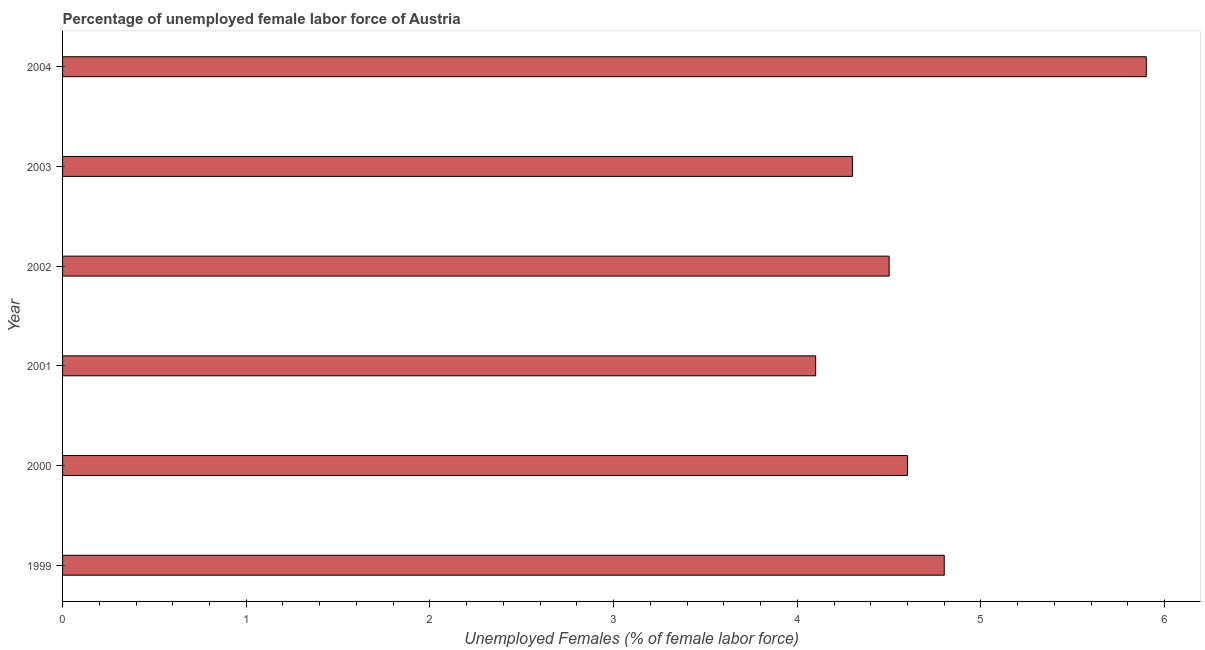Does the graph contain any zero values?
Give a very brief answer. No. What is the title of the graph?
Make the answer very short. Percentage of unemployed female labor force of Austria. What is the label or title of the X-axis?
Give a very brief answer. Unemployed Females (% of female labor force). What is the total unemployed female labour force in 2002?
Ensure brevity in your answer.  4.5. Across all years, what is the maximum total unemployed female labour force?
Make the answer very short. 5.9. Across all years, what is the minimum total unemployed female labour force?
Provide a short and direct response. 4.1. In which year was the total unemployed female labour force minimum?
Provide a succinct answer. 2001. What is the sum of the total unemployed female labour force?
Your answer should be compact. 28.2. What is the difference between the total unemployed female labour force in 2000 and 2003?
Ensure brevity in your answer.  0.3. What is the median total unemployed female labour force?
Your answer should be very brief. 4.55. In how many years, is the total unemployed female labour force greater than 4.8 %?
Provide a succinct answer. 2. What is the ratio of the total unemployed female labour force in 2000 to that in 2003?
Keep it short and to the point. 1.07. Is the difference between the total unemployed female labour force in 1999 and 2003 greater than the difference between any two years?
Offer a very short reply. No. What is the difference between the highest and the second highest total unemployed female labour force?
Your response must be concise. 1.1. Is the sum of the total unemployed female labour force in 2000 and 2003 greater than the maximum total unemployed female labour force across all years?
Your answer should be very brief. Yes. What is the difference between the highest and the lowest total unemployed female labour force?
Keep it short and to the point. 1.8. How many bars are there?
Offer a terse response. 6. What is the difference between two consecutive major ticks on the X-axis?
Make the answer very short. 1. What is the Unemployed Females (% of female labor force) of 1999?
Make the answer very short. 4.8. What is the Unemployed Females (% of female labor force) of 2000?
Your answer should be very brief. 4.6. What is the Unemployed Females (% of female labor force) of 2001?
Provide a succinct answer. 4.1. What is the Unemployed Females (% of female labor force) of 2003?
Make the answer very short. 4.3. What is the Unemployed Females (% of female labor force) in 2004?
Ensure brevity in your answer.  5.9. What is the difference between the Unemployed Females (% of female labor force) in 1999 and 2003?
Offer a terse response. 0.5. What is the difference between the Unemployed Females (% of female labor force) in 2000 and 2002?
Ensure brevity in your answer.  0.1. What is the difference between the Unemployed Females (% of female labor force) in 2000 and 2003?
Your answer should be compact. 0.3. What is the difference between the Unemployed Females (% of female labor force) in 2000 and 2004?
Provide a succinct answer. -1.3. What is the difference between the Unemployed Females (% of female labor force) in 2001 and 2004?
Provide a succinct answer. -1.8. What is the difference between the Unemployed Females (% of female labor force) in 2002 and 2004?
Keep it short and to the point. -1.4. What is the difference between the Unemployed Females (% of female labor force) in 2003 and 2004?
Provide a short and direct response. -1.6. What is the ratio of the Unemployed Females (% of female labor force) in 1999 to that in 2000?
Offer a very short reply. 1.04. What is the ratio of the Unemployed Females (% of female labor force) in 1999 to that in 2001?
Offer a terse response. 1.17. What is the ratio of the Unemployed Females (% of female labor force) in 1999 to that in 2002?
Your response must be concise. 1.07. What is the ratio of the Unemployed Females (% of female labor force) in 1999 to that in 2003?
Give a very brief answer. 1.12. What is the ratio of the Unemployed Females (% of female labor force) in 1999 to that in 2004?
Provide a succinct answer. 0.81. What is the ratio of the Unemployed Females (% of female labor force) in 2000 to that in 2001?
Give a very brief answer. 1.12. What is the ratio of the Unemployed Females (% of female labor force) in 2000 to that in 2003?
Your answer should be very brief. 1.07. What is the ratio of the Unemployed Females (% of female labor force) in 2000 to that in 2004?
Your answer should be compact. 0.78. What is the ratio of the Unemployed Females (% of female labor force) in 2001 to that in 2002?
Your answer should be compact. 0.91. What is the ratio of the Unemployed Females (% of female labor force) in 2001 to that in 2003?
Your answer should be compact. 0.95. What is the ratio of the Unemployed Females (% of female labor force) in 2001 to that in 2004?
Ensure brevity in your answer.  0.69. What is the ratio of the Unemployed Females (% of female labor force) in 2002 to that in 2003?
Provide a short and direct response. 1.05. What is the ratio of the Unemployed Females (% of female labor force) in 2002 to that in 2004?
Your response must be concise. 0.76. What is the ratio of the Unemployed Females (% of female labor force) in 2003 to that in 2004?
Give a very brief answer. 0.73. 